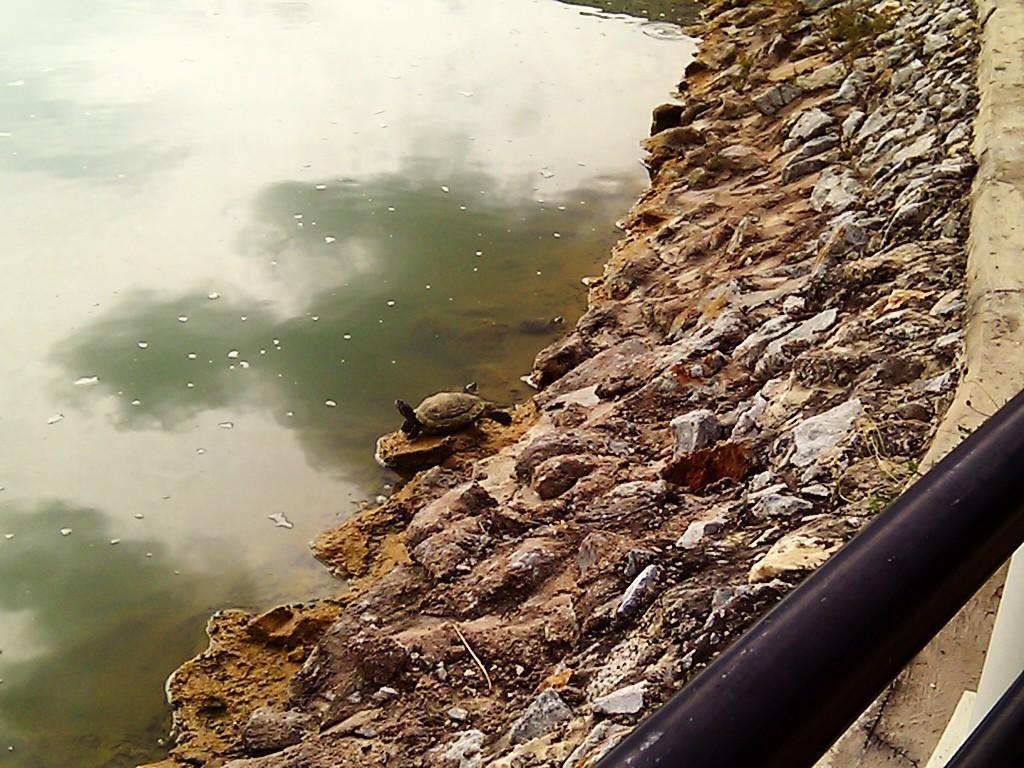Can you describe this image briefly? In this image we can see water on the left side. There are stones. On the right side there is a rod. On the stone there is a tortoise. 